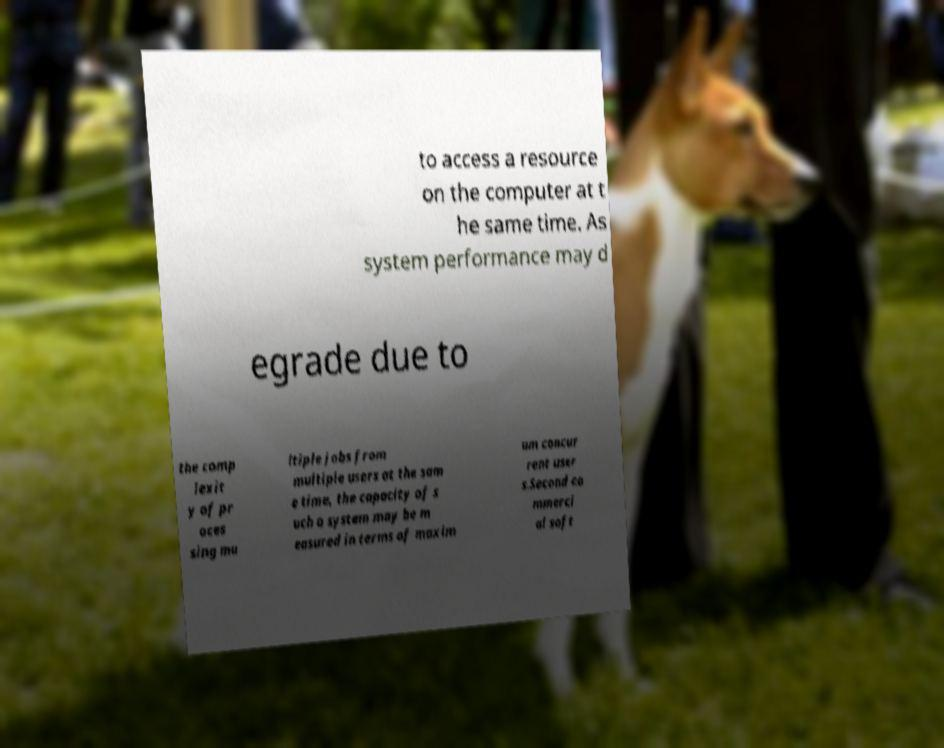Could you extract and type out the text from this image? to access a resource on the computer at t he same time. As system performance may d egrade due to the comp lexit y of pr oces sing mu ltiple jobs from multiple users at the sam e time, the capacity of s uch a system may be m easured in terms of maxim um concur rent user s.Second co mmerci al soft 